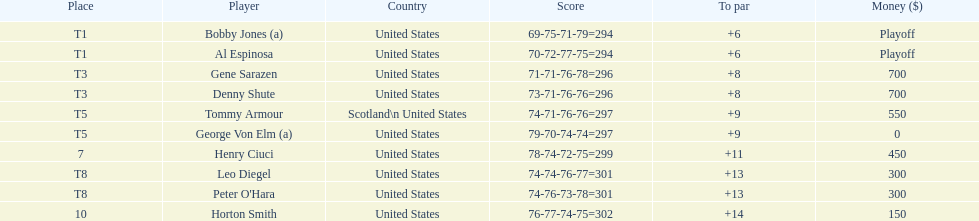Gene sarazen and denny shute are both from which country? United States. 